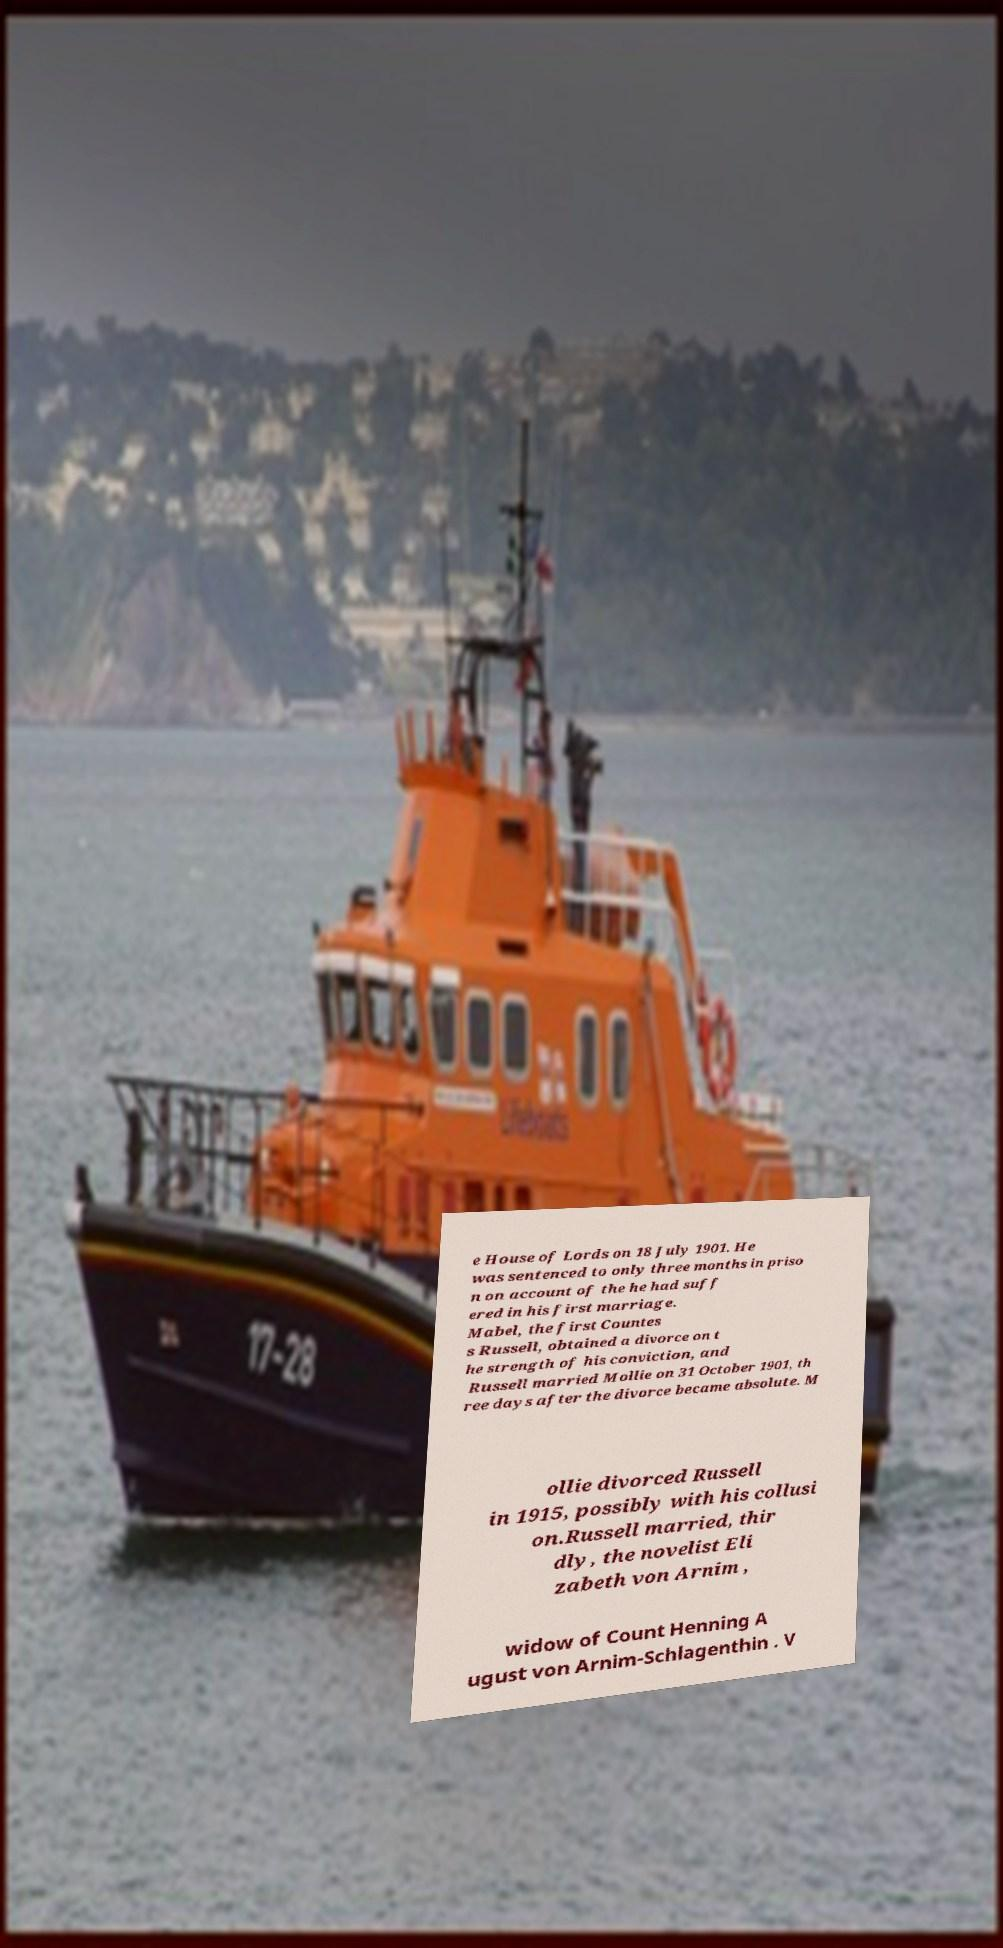Could you extract and type out the text from this image? e House of Lords on 18 July 1901. He was sentenced to only three months in priso n on account of the he had suff ered in his first marriage. Mabel, the first Countes s Russell, obtained a divorce on t he strength of his conviction, and Russell married Mollie on 31 October 1901, th ree days after the divorce became absolute. M ollie divorced Russell in 1915, possibly with his collusi on.Russell married, thir dly, the novelist Eli zabeth von Arnim , widow of Count Henning A ugust von Arnim-Schlagenthin . V 